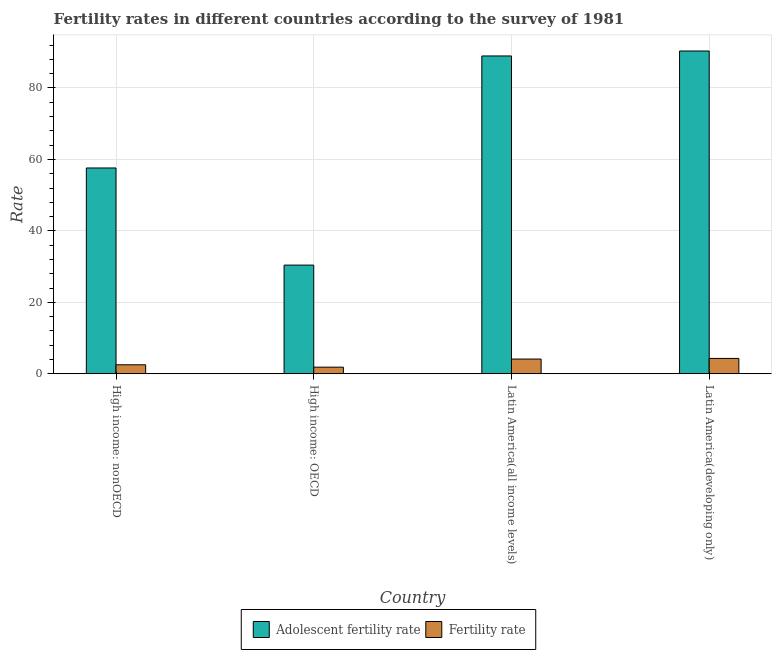How many groups of bars are there?
Your response must be concise. 4. Are the number of bars per tick equal to the number of legend labels?
Give a very brief answer. Yes. Are the number of bars on each tick of the X-axis equal?
Ensure brevity in your answer.  Yes. How many bars are there on the 4th tick from the right?
Your answer should be compact. 2. What is the label of the 2nd group of bars from the left?
Your answer should be compact. High income: OECD. What is the adolescent fertility rate in Latin America(all income levels)?
Provide a short and direct response. 88.97. Across all countries, what is the maximum adolescent fertility rate?
Provide a short and direct response. 90.35. Across all countries, what is the minimum fertility rate?
Offer a very short reply. 1.84. In which country was the fertility rate maximum?
Your answer should be very brief. Latin America(developing only). In which country was the fertility rate minimum?
Offer a very short reply. High income: OECD. What is the total fertility rate in the graph?
Keep it short and to the point. 12.74. What is the difference between the fertility rate in High income: OECD and that in Latin America(all income levels)?
Provide a short and direct response. -2.27. What is the difference between the adolescent fertility rate in Latin America(all income levels) and the fertility rate in High income: OECD?
Offer a terse response. 87.13. What is the average fertility rate per country?
Your answer should be very brief. 3.19. What is the difference between the adolescent fertility rate and fertility rate in High income: OECD?
Your response must be concise. 28.57. In how many countries, is the adolescent fertility rate greater than 76 ?
Your response must be concise. 2. What is the ratio of the fertility rate in High income: nonOECD to that in Latin America(all income levels)?
Offer a very short reply. 0.61. Is the difference between the adolescent fertility rate in Latin America(all income levels) and Latin America(developing only) greater than the difference between the fertility rate in Latin America(all income levels) and Latin America(developing only)?
Offer a terse response. No. What is the difference between the highest and the second highest fertility rate?
Keep it short and to the point. 0.17. What is the difference between the highest and the lowest adolescent fertility rate?
Your answer should be compact. 59.94. Is the sum of the fertility rate in High income: OECD and Latin America(developing only) greater than the maximum adolescent fertility rate across all countries?
Your answer should be compact. No. What does the 1st bar from the left in High income: nonOECD represents?
Your answer should be very brief. Adolescent fertility rate. What does the 1st bar from the right in High income: nonOECD represents?
Your answer should be compact. Fertility rate. How many bars are there?
Your answer should be very brief. 8. Are the values on the major ticks of Y-axis written in scientific E-notation?
Provide a succinct answer. No. Does the graph contain any zero values?
Offer a very short reply. No. Does the graph contain grids?
Keep it short and to the point. Yes. How many legend labels are there?
Make the answer very short. 2. How are the legend labels stacked?
Offer a very short reply. Horizontal. What is the title of the graph?
Your answer should be very brief. Fertility rates in different countries according to the survey of 1981. What is the label or title of the Y-axis?
Provide a short and direct response. Rate. What is the Rate in Adolescent fertility rate in High income: nonOECD?
Give a very brief answer. 57.61. What is the Rate of Fertility rate in High income: nonOECD?
Provide a short and direct response. 2.5. What is the Rate in Adolescent fertility rate in High income: OECD?
Give a very brief answer. 30.41. What is the Rate of Fertility rate in High income: OECD?
Your response must be concise. 1.84. What is the Rate in Adolescent fertility rate in Latin America(all income levels)?
Offer a very short reply. 88.97. What is the Rate in Fertility rate in Latin America(all income levels)?
Your response must be concise. 4.11. What is the Rate in Adolescent fertility rate in Latin America(developing only)?
Your answer should be compact. 90.35. What is the Rate in Fertility rate in Latin America(developing only)?
Provide a short and direct response. 4.29. Across all countries, what is the maximum Rate of Adolescent fertility rate?
Ensure brevity in your answer.  90.35. Across all countries, what is the maximum Rate of Fertility rate?
Ensure brevity in your answer.  4.29. Across all countries, what is the minimum Rate in Adolescent fertility rate?
Provide a short and direct response. 30.41. Across all countries, what is the minimum Rate of Fertility rate?
Your answer should be very brief. 1.84. What is the total Rate of Adolescent fertility rate in the graph?
Give a very brief answer. 267.34. What is the total Rate of Fertility rate in the graph?
Offer a very short reply. 12.74. What is the difference between the Rate in Adolescent fertility rate in High income: nonOECD and that in High income: OECD?
Offer a very short reply. 27.19. What is the difference between the Rate in Fertility rate in High income: nonOECD and that in High income: OECD?
Keep it short and to the point. 0.66. What is the difference between the Rate in Adolescent fertility rate in High income: nonOECD and that in Latin America(all income levels)?
Ensure brevity in your answer.  -31.36. What is the difference between the Rate in Fertility rate in High income: nonOECD and that in Latin America(all income levels)?
Your answer should be compact. -1.61. What is the difference between the Rate of Adolescent fertility rate in High income: nonOECD and that in Latin America(developing only)?
Make the answer very short. -32.75. What is the difference between the Rate of Fertility rate in High income: nonOECD and that in Latin America(developing only)?
Offer a terse response. -1.78. What is the difference between the Rate of Adolescent fertility rate in High income: OECD and that in Latin America(all income levels)?
Your response must be concise. -58.55. What is the difference between the Rate in Fertility rate in High income: OECD and that in Latin America(all income levels)?
Provide a succinct answer. -2.27. What is the difference between the Rate of Adolescent fertility rate in High income: OECD and that in Latin America(developing only)?
Give a very brief answer. -59.94. What is the difference between the Rate in Fertility rate in High income: OECD and that in Latin America(developing only)?
Ensure brevity in your answer.  -2.45. What is the difference between the Rate of Adolescent fertility rate in Latin America(all income levels) and that in Latin America(developing only)?
Give a very brief answer. -1.39. What is the difference between the Rate of Fertility rate in Latin America(all income levels) and that in Latin America(developing only)?
Provide a short and direct response. -0.17. What is the difference between the Rate of Adolescent fertility rate in High income: nonOECD and the Rate of Fertility rate in High income: OECD?
Offer a very short reply. 55.77. What is the difference between the Rate in Adolescent fertility rate in High income: nonOECD and the Rate in Fertility rate in Latin America(all income levels)?
Offer a terse response. 53.5. What is the difference between the Rate in Adolescent fertility rate in High income: nonOECD and the Rate in Fertility rate in Latin America(developing only)?
Your answer should be very brief. 53.32. What is the difference between the Rate of Adolescent fertility rate in High income: OECD and the Rate of Fertility rate in Latin America(all income levels)?
Your answer should be compact. 26.3. What is the difference between the Rate of Adolescent fertility rate in High income: OECD and the Rate of Fertility rate in Latin America(developing only)?
Offer a terse response. 26.13. What is the difference between the Rate in Adolescent fertility rate in Latin America(all income levels) and the Rate in Fertility rate in Latin America(developing only)?
Provide a short and direct response. 84.68. What is the average Rate of Adolescent fertility rate per country?
Give a very brief answer. 66.84. What is the average Rate of Fertility rate per country?
Offer a very short reply. 3.19. What is the difference between the Rate of Adolescent fertility rate and Rate of Fertility rate in High income: nonOECD?
Give a very brief answer. 55.1. What is the difference between the Rate of Adolescent fertility rate and Rate of Fertility rate in High income: OECD?
Offer a terse response. 28.57. What is the difference between the Rate of Adolescent fertility rate and Rate of Fertility rate in Latin America(all income levels)?
Provide a short and direct response. 84.85. What is the difference between the Rate of Adolescent fertility rate and Rate of Fertility rate in Latin America(developing only)?
Your answer should be very brief. 86.07. What is the ratio of the Rate of Adolescent fertility rate in High income: nonOECD to that in High income: OECD?
Your response must be concise. 1.89. What is the ratio of the Rate of Fertility rate in High income: nonOECD to that in High income: OECD?
Make the answer very short. 1.36. What is the ratio of the Rate in Adolescent fertility rate in High income: nonOECD to that in Latin America(all income levels)?
Keep it short and to the point. 0.65. What is the ratio of the Rate in Fertility rate in High income: nonOECD to that in Latin America(all income levels)?
Offer a very short reply. 0.61. What is the ratio of the Rate in Adolescent fertility rate in High income: nonOECD to that in Latin America(developing only)?
Make the answer very short. 0.64. What is the ratio of the Rate of Fertility rate in High income: nonOECD to that in Latin America(developing only)?
Offer a terse response. 0.58. What is the ratio of the Rate of Adolescent fertility rate in High income: OECD to that in Latin America(all income levels)?
Your response must be concise. 0.34. What is the ratio of the Rate in Fertility rate in High income: OECD to that in Latin America(all income levels)?
Make the answer very short. 0.45. What is the ratio of the Rate of Adolescent fertility rate in High income: OECD to that in Latin America(developing only)?
Your response must be concise. 0.34. What is the ratio of the Rate in Fertility rate in High income: OECD to that in Latin America(developing only)?
Make the answer very short. 0.43. What is the ratio of the Rate in Adolescent fertility rate in Latin America(all income levels) to that in Latin America(developing only)?
Your response must be concise. 0.98. What is the ratio of the Rate of Fertility rate in Latin America(all income levels) to that in Latin America(developing only)?
Offer a terse response. 0.96. What is the difference between the highest and the second highest Rate of Adolescent fertility rate?
Give a very brief answer. 1.39. What is the difference between the highest and the second highest Rate in Fertility rate?
Provide a succinct answer. 0.17. What is the difference between the highest and the lowest Rate in Adolescent fertility rate?
Offer a very short reply. 59.94. What is the difference between the highest and the lowest Rate of Fertility rate?
Provide a short and direct response. 2.45. 